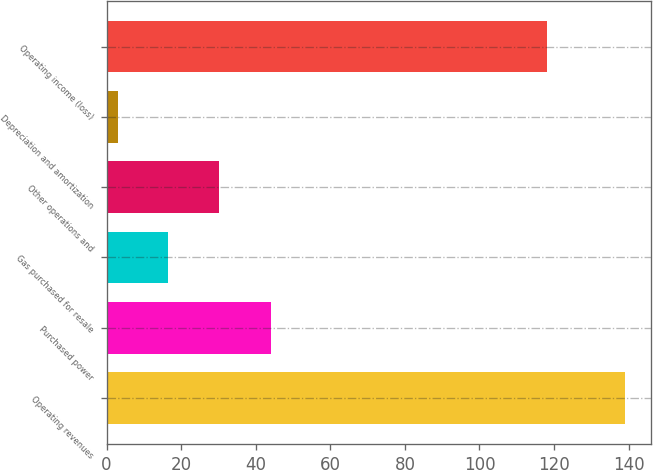Convert chart. <chart><loc_0><loc_0><loc_500><loc_500><bar_chart><fcel>Operating revenues<fcel>Purchased power<fcel>Gas purchased for resale<fcel>Other operations and<fcel>Depreciation and amortization<fcel>Operating income (loss)<nl><fcel>139<fcel>44<fcel>16.6<fcel>30.2<fcel>3<fcel>118<nl></chart> 